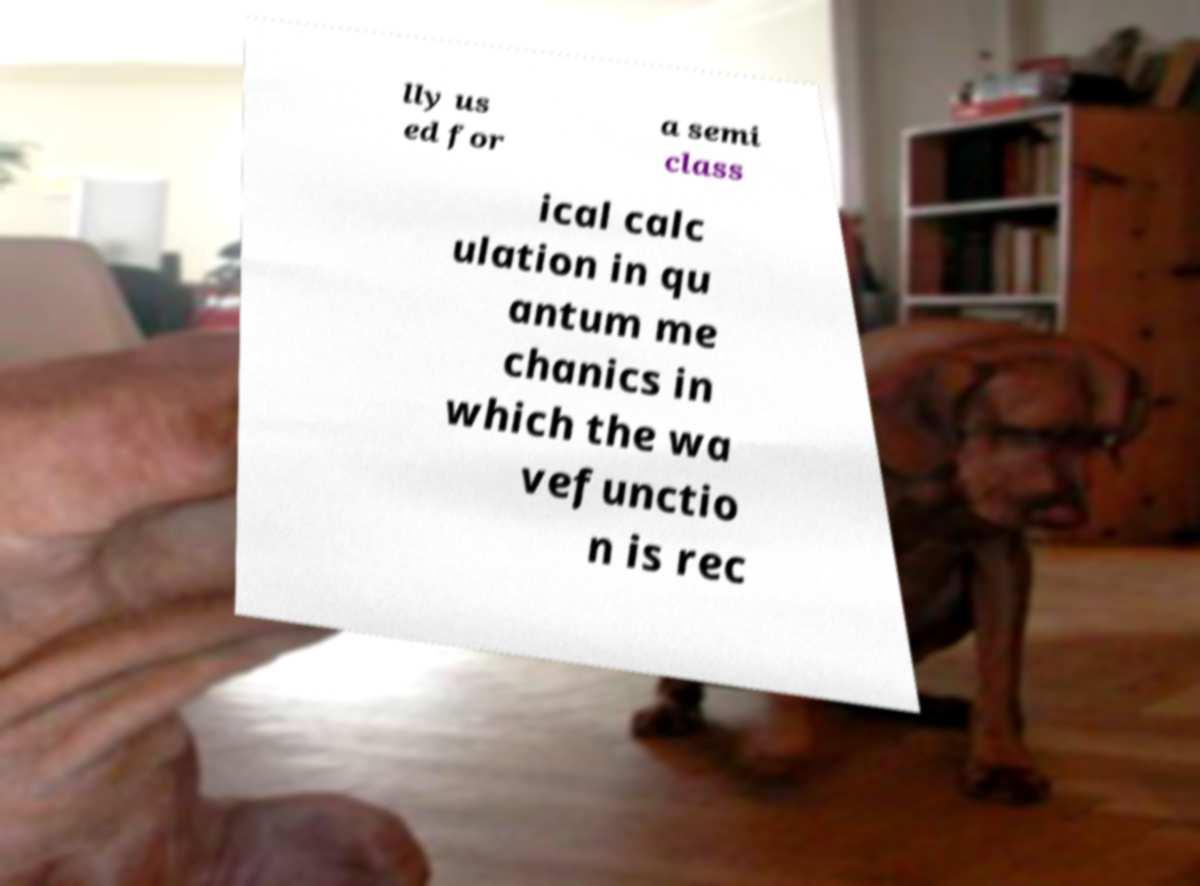Could you assist in decoding the text presented in this image and type it out clearly? lly us ed for a semi class ical calc ulation in qu antum me chanics in which the wa vefunctio n is rec 